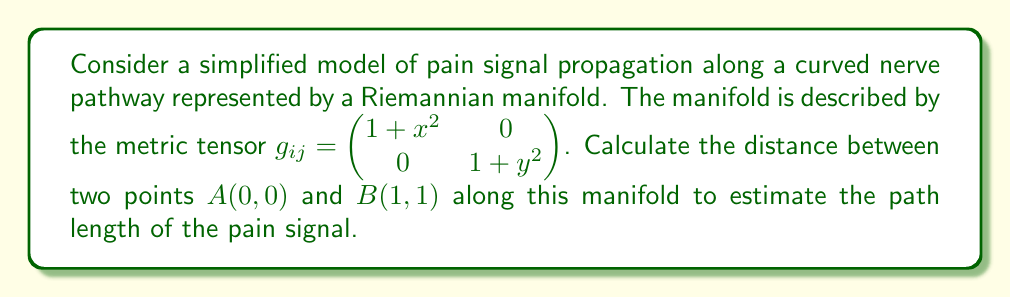What is the answer to this math problem? To calculate the distance between two points on a Riemannian manifold, we need to use the formula for the length of a curve:

$$L = \int_a^b \sqrt{g_{ij}\frac{dx^i}{dt}\frac{dx^j}{dt}}dt$$

where $g_{ij}$ is the metric tensor, and $\frac{dx^i}{dt}$ and $\frac{dx^j}{dt}$ are the components of the velocity vector.

Step 1: Parameterize the curve
Let's assume a straight line path between A and B:
$x(t) = t$, $y(t) = t$, where $0 \leq t \leq 1$

Step 2: Calculate the derivatives
$\frac{dx}{dt} = 1$, $\frac{dy}{dt} = 1$

Step 3: Substitute into the length formula
$$L = \int_0^1 \sqrt{g_{11}(\frac{dx}{dt})^2 + g_{22}(\frac{dy}{dt})^2}dt$$
$$L = \int_0^1 \sqrt{(1+t^2)(1)^2 + (1+t^2)(1)^2}dt$$
$$L = \int_0^1 \sqrt{2(1+t^2)}dt$$

Step 4: Simplify and integrate
$$L = \sqrt{2}\int_0^1 \sqrt{1+t^2}dt$$

This integral can be solved using the substitution $t = \tan\theta$:

$$L = \sqrt{2}[\frac{1}{2}(t\sqrt{1+t^2} + \ln(t + \sqrt{1+t^2}))]_0^1$$

Step 5: Evaluate the integral
$$L = \sqrt{2}[\frac{1}{2}(\sqrt{2} + \ln(1 + \sqrt{2})) - 0]$$

$$L = \frac{1}{\sqrt{2}}(\sqrt{2} + \ln(1 + \sqrt{2}))$$
Answer: $\frac{1}{\sqrt{2}}(\sqrt{2} + \ln(1 + \sqrt{2}))$ 